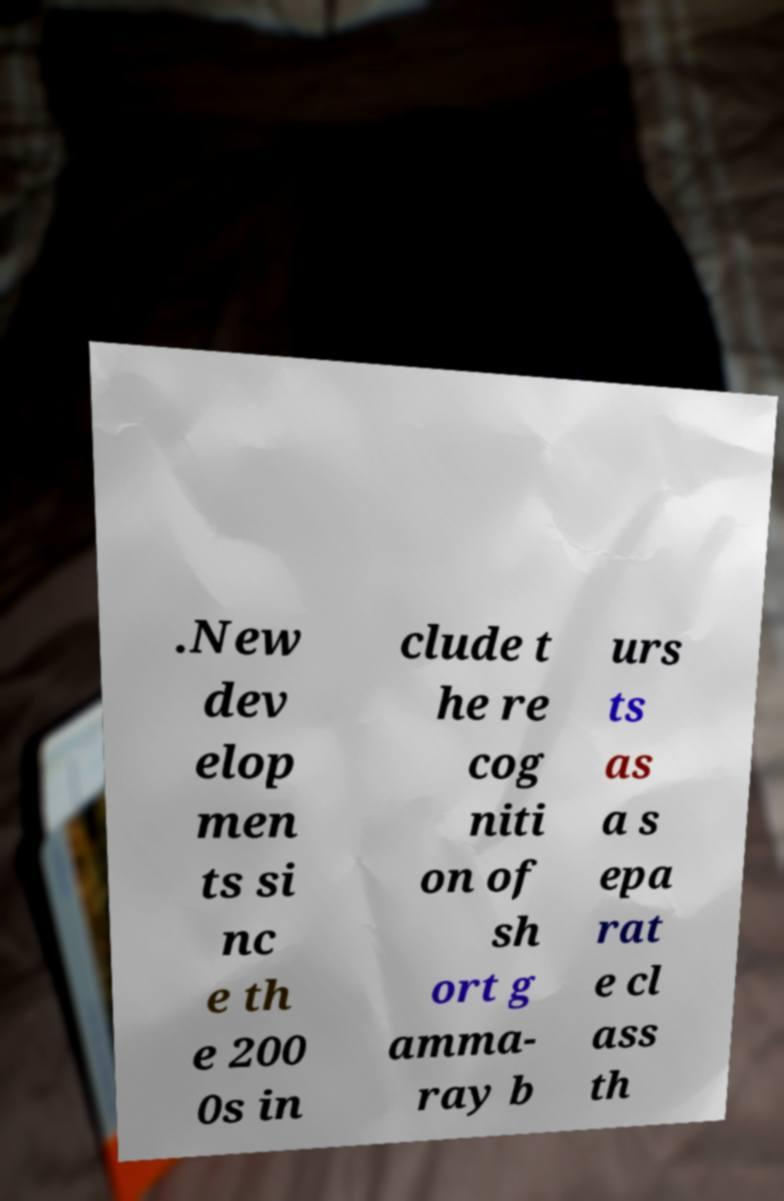Please identify and transcribe the text found in this image. .New dev elop men ts si nc e th e 200 0s in clude t he re cog niti on of sh ort g amma- ray b urs ts as a s epa rat e cl ass th 